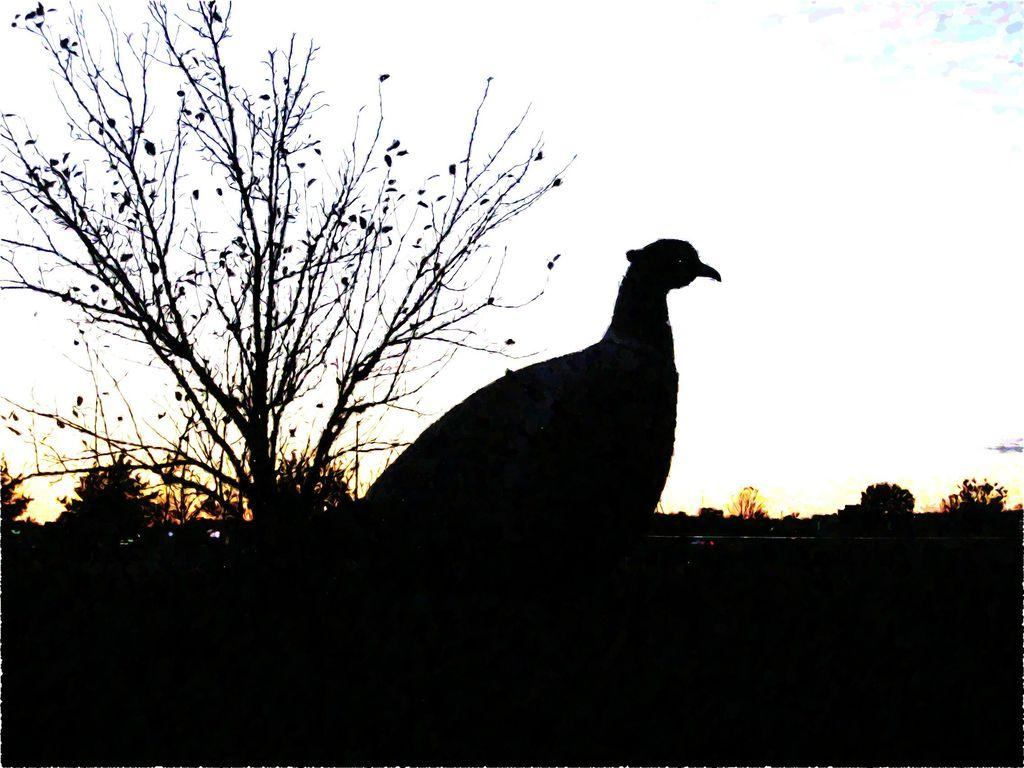What type of animal can be seen in the image? There is a bird in the image. Where is the bird located in the image? The bird is standing on the ground. What can be seen in the background of the image? There are trees in the background of the image. What is visible at the top of the image? The sky is visible at the top of the image. What can be observed in the sky? Clouds are present in the sky. What type of credit can be seen being offered to the bird in the image? There is no credit being offered to the bird in the image. What advice is the bird receiving from the trees in the background? The trees in the background are not providing any advice to the bird in the image. 